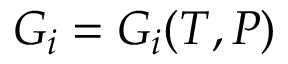Convert formula to latex. <formula><loc_0><loc_0><loc_500><loc_500>G _ { i } = G _ { i } ( T , P )</formula> 